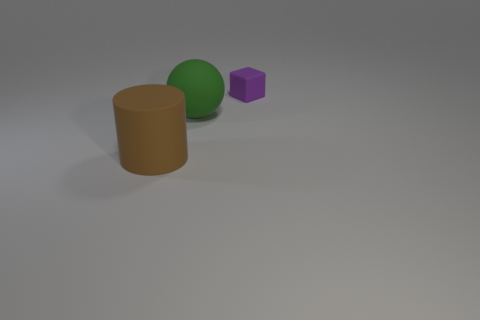Are there the same number of purple matte objects on the right side of the small purple rubber thing and brown matte cylinders?
Provide a short and direct response. No. What is the shape of the green object?
Your response must be concise. Sphere. Do the object that is to the left of the big green matte sphere and the thing to the right of the big green thing have the same size?
Keep it short and to the point. No. There is a matte object that is in front of the large matte object that is behind the brown matte cylinder; what shape is it?
Keep it short and to the point. Cylinder. Is the size of the brown thing the same as the rubber object that is behind the large green matte sphere?
Provide a short and direct response. No. What size is the thing left of the large rubber thing on the right side of the object that is on the left side of the large green rubber ball?
Provide a short and direct response. Large. How many objects are matte things in front of the tiny purple block or tiny red rubber balls?
Offer a very short reply. 2. What number of purple rubber objects are to the right of the thing behind the large green rubber object?
Your response must be concise. 0. Is the number of small purple objects behind the brown matte cylinder greater than the number of big cyan matte spheres?
Your answer should be very brief. Yes. There is a rubber object that is both right of the big matte cylinder and to the left of the tiny purple thing; what is its size?
Your answer should be very brief. Large. 